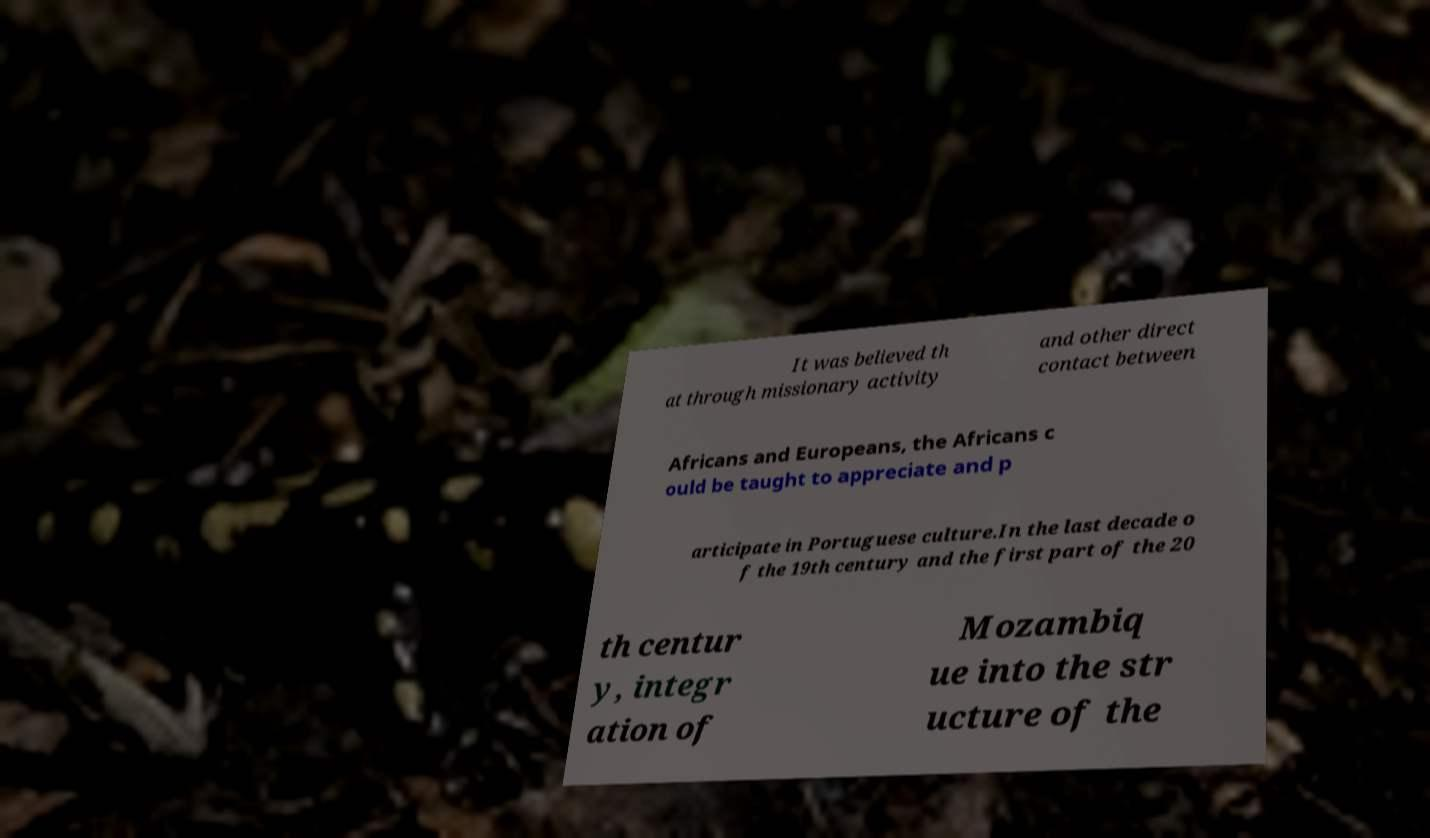Could you assist in decoding the text presented in this image and type it out clearly? It was believed th at through missionary activity and other direct contact between Africans and Europeans, the Africans c ould be taught to appreciate and p articipate in Portuguese culture.In the last decade o f the 19th century and the first part of the 20 th centur y, integr ation of Mozambiq ue into the str ucture of the 